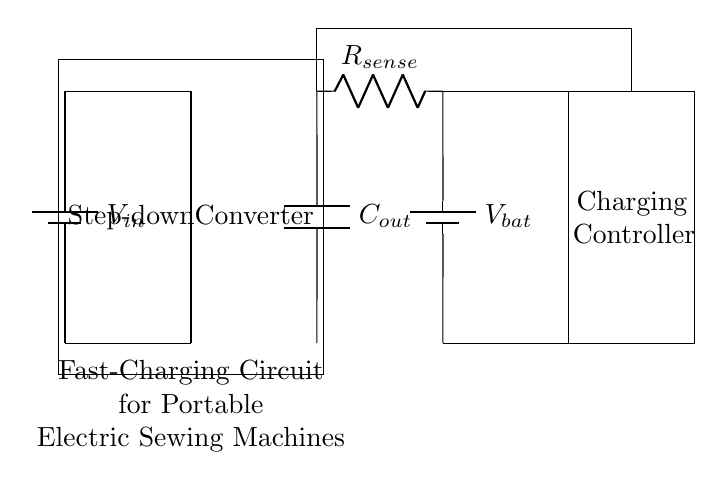What is the input voltage represented in the circuit? The input voltage is represented by the battery labeled V_in, which is the source connected to the charging circuit.
Answer: V_in What is the purpose of the step-down converter in the circuit? The step-down converter reduces the input voltage to a lower level suitable for charging the battery, ensuring that the voltage is appropriate for the charging process.
Answer: Voltage regulation What component is responsible for sensing current during charging? The current sensing resistor labeled R_sense is designed to monitor the current flowing through the charging circuit.
Answer: R_sense What replaces the battery during the charging process? During charging, the output from the charging controller connects to the battery labeled V_bat, effectively replacing it by directing energy into the battery until it's fully charged.
Answer: V_bat How does the output capacitor function in this circuit? The output capacitor labeled C_out stores energy and helps stabilize the voltage output, smoothing any fluctuations and providing steady power to the battery during charging.
Answer: Energy storage What is the role of the charging controller in the circuit? The charging controller manages the charging process by regulating the voltage and current supplied to the battery, ensuring safe and efficient charging without overcharging.
Answer: Charge management 